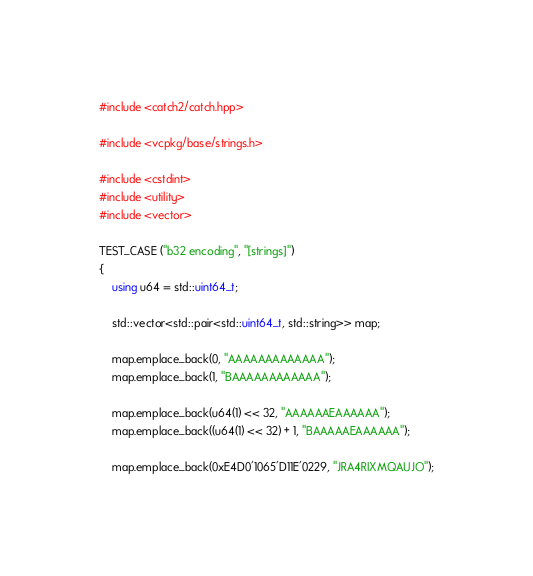<code> <loc_0><loc_0><loc_500><loc_500><_C++_>#include <catch2/catch.hpp>

#include <vcpkg/base/strings.h>

#include <cstdint>
#include <utility>
#include <vector>

TEST_CASE ("b32 encoding", "[strings]")
{
    using u64 = std::uint64_t;

    std::vector<std::pair<std::uint64_t, std::string>> map;

    map.emplace_back(0, "AAAAAAAAAAAAA");
    map.emplace_back(1, "BAAAAAAAAAAAA");

    map.emplace_back(u64(1) << 32, "AAAAAAEAAAAAA");
    map.emplace_back((u64(1) << 32) + 1, "BAAAAAEAAAAAA");

    map.emplace_back(0xE4D0'1065'D11E'0229, "JRA4RIXMQAUJO");</code> 